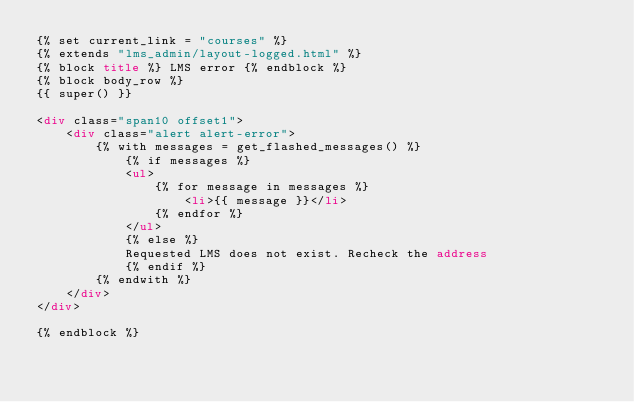Convert code to text. <code><loc_0><loc_0><loc_500><loc_500><_HTML_>{% set current_link = "courses" %}
{% extends "lms_admin/layout-logged.html" %}
{% block title %} LMS error {% endblock %}
{% block body_row %}
{{ super() }}

<div class="span10 offset1">
    <div class="alert alert-error">
        {% with messages = get_flashed_messages() %}
            {% if messages %}
            <ul>
                {% for message in messages %}
                    <li>{{ message }}</li>
                {% endfor %}
            </ul>
            {% else %}
            Requested LMS does not exist. Recheck the address
            {% endif %}
        {% endwith %}
    </div>
</div>

{% endblock %}
</code> 